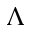<formula> <loc_0><loc_0><loc_500><loc_500>\Lambda</formula> 